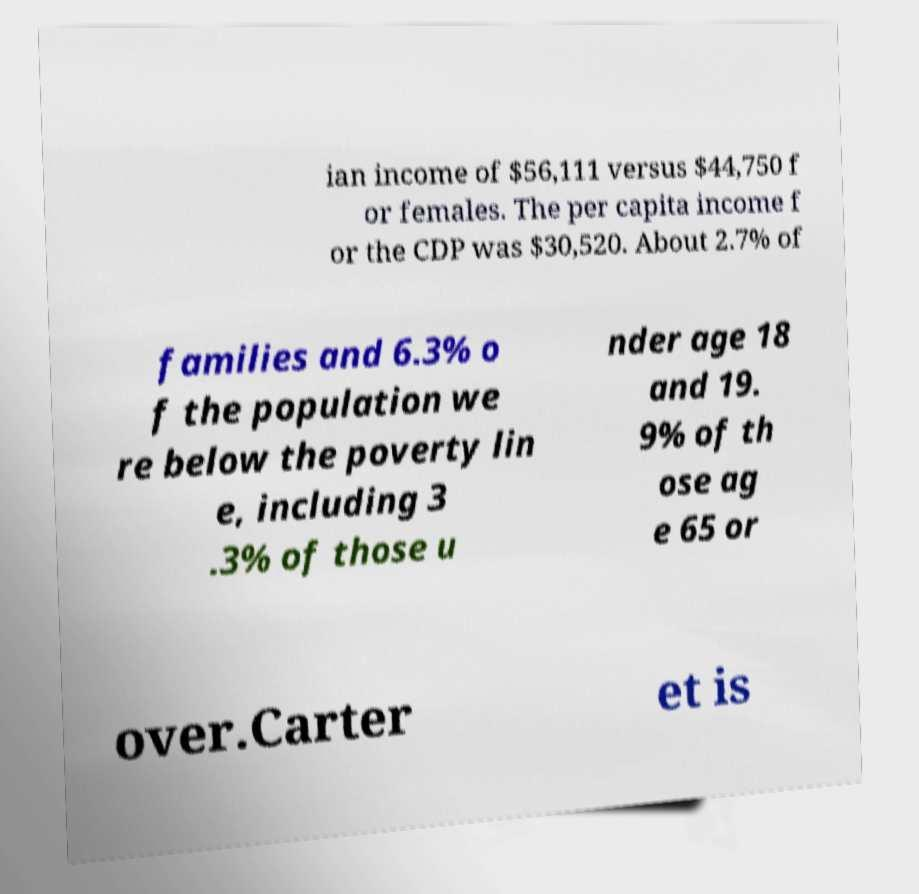I need the written content from this picture converted into text. Can you do that? ian income of $56,111 versus $44,750 f or females. The per capita income f or the CDP was $30,520. About 2.7% of families and 6.3% o f the population we re below the poverty lin e, including 3 .3% of those u nder age 18 and 19. 9% of th ose ag e 65 or over.Carter et is 